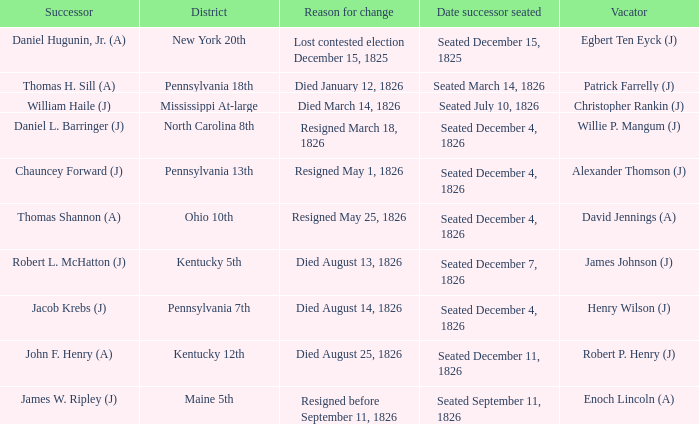Name the reason for change pennsylvania 13th Resigned May 1, 1826. 